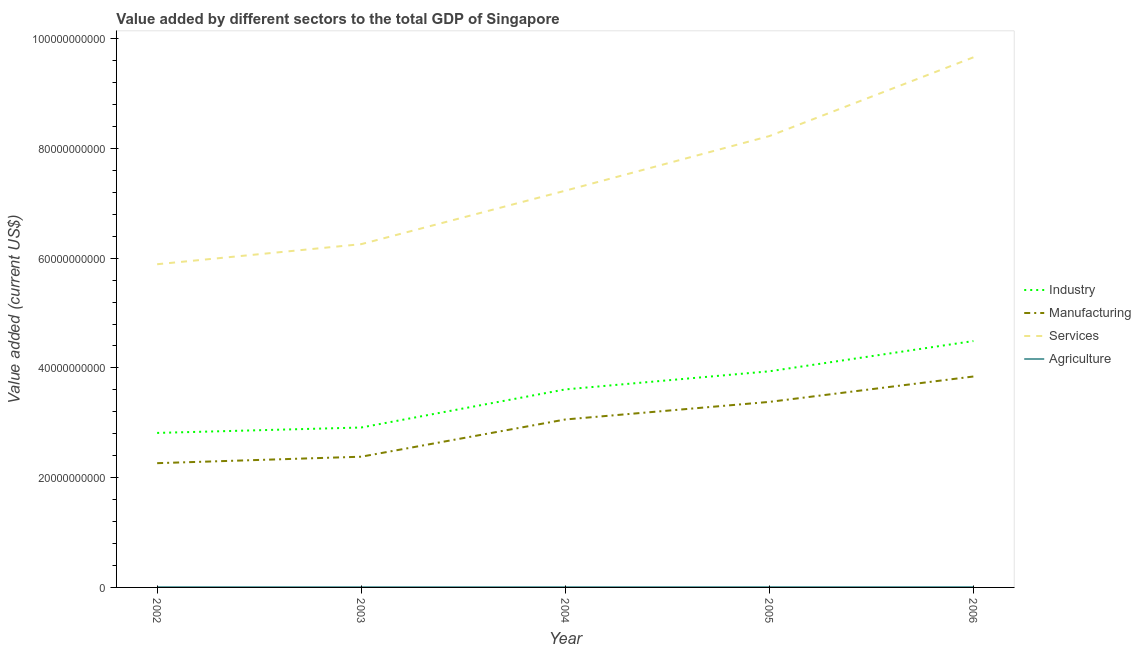Does the line corresponding to value added by services sector intersect with the line corresponding to value added by agricultural sector?
Your answer should be very brief. No. What is the value added by agricultural sector in 2004?
Offer a terse response. 6.39e+07. Across all years, what is the maximum value added by industrial sector?
Your answer should be very brief. 4.49e+1. Across all years, what is the minimum value added by industrial sector?
Ensure brevity in your answer.  2.82e+1. In which year was the value added by manufacturing sector minimum?
Give a very brief answer. 2002. What is the total value added by services sector in the graph?
Give a very brief answer. 3.73e+11. What is the difference between the value added by industrial sector in 2004 and that in 2006?
Your answer should be compact. -8.81e+09. What is the difference between the value added by industrial sector in 2005 and the value added by agricultural sector in 2003?
Keep it short and to the point. 3.93e+1. What is the average value added by manufacturing sector per year?
Offer a terse response. 2.99e+1. In the year 2002, what is the difference between the value added by services sector and value added by industrial sector?
Your response must be concise. 3.07e+1. In how many years, is the value added by services sector greater than 32000000000 US$?
Make the answer very short. 5. What is the ratio of the value added by industrial sector in 2004 to that in 2005?
Ensure brevity in your answer.  0.92. Is the value added by manufacturing sector in 2003 less than that in 2005?
Offer a very short reply. Yes. What is the difference between the highest and the second highest value added by services sector?
Provide a succinct answer. 1.44e+1. What is the difference between the highest and the lowest value added by services sector?
Provide a short and direct response. 3.77e+1. In how many years, is the value added by manufacturing sector greater than the average value added by manufacturing sector taken over all years?
Provide a short and direct response. 3. Is the sum of the value added by industrial sector in 2002 and 2005 greater than the maximum value added by services sector across all years?
Give a very brief answer. No. Is it the case that in every year, the sum of the value added by industrial sector and value added by manufacturing sector is greater than the value added by services sector?
Your answer should be compact. No. Does the value added by manufacturing sector monotonically increase over the years?
Make the answer very short. Yes. How many lines are there?
Keep it short and to the point. 4. Does the graph contain any zero values?
Your answer should be compact. No. Where does the legend appear in the graph?
Your answer should be very brief. Center right. How many legend labels are there?
Your response must be concise. 4. What is the title of the graph?
Ensure brevity in your answer.  Value added by different sectors to the total GDP of Singapore. Does "Pre-primary schools" appear as one of the legend labels in the graph?
Your response must be concise. No. What is the label or title of the X-axis?
Ensure brevity in your answer.  Year. What is the label or title of the Y-axis?
Keep it short and to the point. Value added (current US$). What is the Value added (current US$) of Industry in 2002?
Your answer should be compact. 2.82e+1. What is the Value added (current US$) of Manufacturing in 2002?
Your answer should be compact. 2.26e+1. What is the Value added (current US$) of Services in 2002?
Provide a succinct answer. 5.89e+1. What is the Value added (current US$) in Agriculture in 2002?
Make the answer very short. 6.56e+07. What is the Value added (current US$) in Industry in 2003?
Make the answer very short. 2.91e+1. What is the Value added (current US$) of Manufacturing in 2003?
Make the answer very short. 2.38e+1. What is the Value added (current US$) of Services in 2003?
Keep it short and to the point. 6.26e+1. What is the Value added (current US$) in Agriculture in 2003?
Your response must be concise. 5.96e+07. What is the Value added (current US$) in Industry in 2004?
Provide a succinct answer. 3.61e+1. What is the Value added (current US$) in Manufacturing in 2004?
Offer a terse response. 3.06e+1. What is the Value added (current US$) in Services in 2004?
Offer a very short reply. 7.23e+1. What is the Value added (current US$) of Agriculture in 2004?
Your response must be concise. 6.39e+07. What is the Value added (current US$) of Industry in 2005?
Your answer should be compact. 3.94e+1. What is the Value added (current US$) of Manufacturing in 2005?
Offer a terse response. 3.38e+1. What is the Value added (current US$) in Services in 2005?
Make the answer very short. 8.23e+1. What is the Value added (current US$) in Agriculture in 2005?
Give a very brief answer. 7.02e+07. What is the Value added (current US$) of Industry in 2006?
Provide a succinct answer. 4.49e+1. What is the Value added (current US$) of Manufacturing in 2006?
Provide a short and direct response. 3.84e+1. What is the Value added (current US$) of Services in 2006?
Your response must be concise. 9.66e+1. What is the Value added (current US$) in Agriculture in 2006?
Make the answer very short. 7.24e+07. Across all years, what is the maximum Value added (current US$) of Industry?
Provide a short and direct response. 4.49e+1. Across all years, what is the maximum Value added (current US$) in Manufacturing?
Offer a very short reply. 3.84e+1. Across all years, what is the maximum Value added (current US$) in Services?
Ensure brevity in your answer.  9.66e+1. Across all years, what is the maximum Value added (current US$) in Agriculture?
Give a very brief answer. 7.24e+07. Across all years, what is the minimum Value added (current US$) in Industry?
Your response must be concise. 2.82e+1. Across all years, what is the minimum Value added (current US$) in Manufacturing?
Your response must be concise. 2.26e+1. Across all years, what is the minimum Value added (current US$) in Services?
Your answer should be compact. 5.89e+1. Across all years, what is the minimum Value added (current US$) of Agriculture?
Provide a short and direct response. 5.96e+07. What is the total Value added (current US$) of Industry in the graph?
Offer a terse response. 1.78e+11. What is the total Value added (current US$) in Manufacturing in the graph?
Your response must be concise. 1.49e+11. What is the total Value added (current US$) of Services in the graph?
Ensure brevity in your answer.  3.73e+11. What is the total Value added (current US$) in Agriculture in the graph?
Offer a terse response. 3.32e+08. What is the difference between the Value added (current US$) in Industry in 2002 and that in 2003?
Your answer should be very brief. -9.86e+08. What is the difference between the Value added (current US$) of Manufacturing in 2002 and that in 2003?
Offer a terse response. -1.18e+09. What is the difference between the Value added (current US$) in Services in 2002 and that in 2003?
Provide a short and direct response. -3.66e+09. What is the difference between the Value added (current US$) of Agriculture in 2002 and that in 2003?
Your answer should be compact. 5.98e+06. What is the difference between the Value added (current US$) of Industry in 2002 and that in 2004?
Give a very brief answer. -7.93e+09. What is the difference between the Value added (current US$) in Manufacturing in 2002 and that in 2004?
Provide a succinct answer. -7.96e+09. What is the difference between the Value added (current US$) in Services in 2002 and that in 2004?
Your answer should be compact. -1.34e+1. What is the difference between the Value added (current US$) in Agriculture in 2002 and that in 2004?
Your answer should be compact. 1.67e+06. What is the difference between the Value added (current US$) of Industry in 2002 and that in 2005?
Provide a succinct answer. -1.12e+1. What is the difference between the Value added (current US$) of Manufacturing in 2002 and that in 2005?
Provide a short and direct response. -1.12e+1. What is the difference between the Value added (current US$) in Services in 2002 and that in 2005?
Give a very brief answer. -2.34e+1. What is the difference between the Value added (current US$) in Agriculture in 2002 and that in 2005?
Provide a short and direct response. -4.61e+06. What is the difference between the Value added (current US$) of Industry in 2002 and that in 2006?
Your response must be concise. -1.67e+1. What is the difference between the Value added (current US$) in Manufacturing in 2002 and that in 2006?
Provide a succinct answer. -1.58e+1. What is the difference between the Value added (current US$) of Services in 2002 and that in 2006?
Give a very brief answer. -3.77e+1. What is the difference between the Value added (current US$) in Agriculture in 2002 and that in 2006?
Your answer should be very brief. -6.88e+06. What is the difference between the Value added (current US$) in Industry in 2003 and that in 2004?
Provide a succinct answer. -6.94e+09. What is the difference between the Value added (current US$) in Manufacturing in 2003 and that in 2004?
Keep it short and to the point. -6.78e+09. What is the difference between the Value added (current US$) of Services in 2003 and that in 2004?
Offer a very short reply. -9.74e+09. What is the difference between the Value added (current US$) in Agriculture in 2003 and that in 2004?
Provide a short and direct response. -4.32e+06. What is the difference between the Value added (current US$) of Industry in 2003 and that in 2005?
Offer a terse response. -1.02e+1. What is the difference between the Value added (current US$) in Manufacturing in 2003 and that in 2005?
Give a very brief answer. -9.99e+09. What is the difference between the Value added (current US$) of Services in 2003 and that in 2005?
Your response must be concise. -1.97e+1. What is the difference between the Value added (current US$) in Agriculture in 2003 and that in 2005?
Your response must be concise. -1.06e+07. What is the difference between the Value added (current US$) in Industry in 2003 and that in 2006?
Make the answer very short. -1.58e+1. What is the difference between the Value added (current US$) of Manufacturing in 2003 and that in 2006?
Offer a terse response. -1.46e+1. What is the difference between the Value added (current US$) in Services in 2003 and that in 2006?
Offer a terse response. -3.41e+1. What is the difference between the Value added (current US$) in Agriculture in 2003 and that in 2006?
Ensure brevity in your answer.  -1.29e+07. What is the difference between the Value added (current US$) of Industry in 2004 and that in 2005?
Your response must be concise. -3.30e+09. What is the difference between the Value added (current US$) of Manufacturing in 2004 and that in 2005?
Provide a succinct answer. -3.21e+09. What is the difference between the Value added (current US$) of Services in 2004 and that in 2005?
Ensure brevity in your answer.  -9.95e+09. What is the difference between the Value added (current US$) in Agriculture in 2004 and that in 2005?
Offer a terse response. -6.28e+06. What is the difference between the Value added (current US$) in Industry in 2004 and that in 2006?
Provide a succinct answer. -8.81e+09. What is the difference between the Value added (current US$) of Manufacturing in 2004 and that in 2006?
Your answer should be very brief. -7.83e+09. What is the difference between the Value added (current US$) in Services in 2004 and that in 2006?
Your answer should be compact. -2.43e+1. What is the difference between the Value added (current US$) in Agriculture in 2004 and that in 2006?
Your answer should be compact. -8.54e+06. What is the difference between the Value added (current US$) of Industry in 2005 and that in 2006?
Provide a succinct answer. -5.51e+09. What is the difference between the Value added (current US$) in Manufacturing in 2005 and that in 2006?
Ensure brevity in your answer.  -4.63e+09. What is the difference between the Value added (current US$) of Services in 2005 and that in 2006?
Offer a terse response. -1.44e+1. What is the difference between the Value added (current US$) of Agriculture in 2005 and that in 2006?
Give a very brief answer. -2.26e+06. What is the difference between the Value added (current US$) in Industry in 2002 and the Value added (current US$) in Manufacturing in 2003?
Give a very brief answer. 4.33e+09. What is the difference between the Value added (current US$) in Industry in 2002 and the Value added (current US$) in Services in 2003?
Provide a short and direct response. -3.44e+1. What is the difference between the Value added (current US$) in Industry in 2002 and the Value added (current US$) in Agriculture in 2003?
Give a very brief answer. 2.81e+1. What is the difference between the Value added (current US$) of Manufacturing in 2002 and the Value added (current US$) of Services in 2003?
Your response must be concise. -3.99e+1. What is the difference between the Value added (current US$) in Manufacturing in 2002 and the Value added (current US$) in Agriculture in 2003?
Offer a terse response. 2.26e+1. What is the difference between the Value added (current US$) of Services in 2002 and the Value added (current US$) of Agriculture in 2003?
Offer a terse response. 5.88e+1. What is the difference between the Value added (current US$) in Industry in 2002 and the Value added (current US$) in Manufacturing in 2004?
Your answer should be very brief. -2.45e+09. What is the difference between the Value added (current US$) in Industry in 2002 and the Value added (current US$) in Services in 2004?
Your response must be concise. -4.41e+1. What is the difference between the Value added (current US$) of Industry in 2002 and the Value added (current US$) of Agriculture in 2004?
Keep it short and to the point. 2.81e+1. What is the difference between the Value added (current US$) of Manufacturing in 2002 and the Value added (current US$) of Services in 2004?
Offer a very short reply. -4.97e+1. What is the difference between the Value added (current US$) of Manufacturing in 2002 and the Value added (current US$) of Agriculture in 2004?
Ensure brevity in your answer.  2.26e+1. What is the difference between the Value added (current US$) in Services in 2002 and the Value added (current US$) in Agriculture in 2004?
Ensure brevity in your answer.  5.88e+1. What is the difference between the Value added (current US$) in Industry in 2002 and the Value added (current US$) in Manufacturing in 2005?
Offer a terse response. -5.66e+09. What is the difference between the Value added (current US$) in Industry in 2002 and the Value added (current US$) in Services in 2005?
Your answer should be compact. -5.41e+1. What is the difference between the Value added (current US$) of Industry in 2002 and the Value added (current US$) of Agriculture in 2005?
Provide a short and direct response. 2.81e+1. What is the difference between the Value added (current US$) in Manufacturing in 2002 and the Value added (current US$) in Services in 2005?
Make the answer very short. -5.96e+1. What is the difference between the Value added (current US$) in Manufacturing in 2002 and the Value added (current US$) in Agriculture in 2005?
Make the answer very short. 2.26e+1. What is the difference between the Value added (current US$) in Services in 2002 and the Value added (current US$) in Agriculture in 2005?
Ensure brevity in your answer.  5.88e+1. What is the difference between the Value added (current US$) in Industry in 2002 and the Value added (current US$) in Manufacturing in 2006?
Your answer should be compact. -1.03e+1. What is the difference between the Value added (current US$) in Industry in 2002 and the Value added (current US$) in Services in 2006?
Make the answer very short. -6.85e+1. What is the difference between the Value added (current US$) of Industry in 2002 and the Value added (current US$) of Agriculture in 2006?
Make the answer very short. 2.81e+1. What is the difference between the Value added (current US$) of Manufacturing in 2002 and the Value added (current US$) of Services in 2006?
Your answer should be very brief. -7.40e+1. What is the difference between the Value added (current US$) of Manufacturing in 2002 and the Value added (current US$) of Agriculture in 2006?
Your response must be concise. 2.26e+1. What is the difference between the Value added (current US$) of Services in 2002 and the Value added (current US$) of Agriculture in 2006?
Give a very brief answer. 5.88e+1. What is the difference between the Value added (current US$) in Industry in 2003 and the Value added (current US$) in Manufacturing in 2004?
Your answer should be compact. -1.46e+09. What is the difference between the Value added (current US$) in Industry in 2003 and the Value added (current US$) in Services in 2004?
Give a very brief answer. -4.32e+1. What is the difference between the Value added (current US$) of Industry in 2003 and the Value added (current US$) of Agriculture in 2004?
Offer a terse response. 2.91e+1. What is the difference between the Value added (current US$) in Manufacturing in 2003 and the Value added (current US$) in Services in 2004?
Your answer should be very brief. -4.85e+1. What is the difference between the Value added (current US$) of Manufacturing in 2003 and the Value added (current US$) of Agriculture in 2004?
Provide a short and direct response. 2.38e+1. What is the difference between the Value added (current US$) in Services in 2003 and the Value added (current US$) in Agriculture in 2004?
Provide a succinct answer. 6.25e+1. What is the difference between the Value added (current US$) of Industry in 2003 and the Value added (current US$) of Manufacturing in 2005?
Keep it short and to the point. -4.67e+09. What is the difference between the Value added (current US$) of Industry in 2003 and the Value added (current US$) of Services in 2005?
Your answer should be compact. -5.31e+1. What is the difference between the Value added (current US$) in Industry in 2003 and the Value added (current US$) in Agriculture in 2005?
Your answer should be very brief. 2.91e+1. What is the difference between the Value added (current US$) in Manufacturing in 2003 and the Value added (current US$) in Services in 2005?
Your answer should be very brief. -5.84e+1. What is the difference between the Value added (current US$) of Manufacturing in 2003 and the Value added (current US$) of Agriculture in 2005?
Offer a terse response. 2.38e+1. What is the difference between the Value added (current US$) in Services in 2003 and the Value added (current US$) in Agriculture in 2005?
Ensure brevity in your answer.  6.25e+1. What is the difference between the Value added (current US$) of Industry in 2003 and the Value added (current US$) of Manufacturing in 2006?
Ensure brevity in your answer.  -9.30e+09. What is the difference between the Value added (current US$) of Industry in 2003 and the Value added (current US$) of Services in 2006?
Offer a terse response. -6.75e+1. What is the difference between the Value added (current US$) of Industry in 2003 and the Value added (current US$) of Agriculture in 2006?
Keep it short and to the point. 2.91e+1. What is the difference between the Value added (current US$) in Manufacturing in 2003 and the Value added (current US$) in Services in 2006?
Provide a short and direct response. -7.28e+1. What is the difference between the Value added (current US$) of Manufacturing in 2003 and the Value added (current US$) of Agriculture in 2006?
Provide a short and direct response. 2.38e+1. What is the difference between the Value added (current US$) of Services in 2003 and the Value added (current US$) of Agriculture in 2006?
Make the answer very short. 6.25e+1. What is the difference between the Value added (current US$) in Industry in 2004 and the Value added (current US$) in Manufacturing in 2005?
Provide a succinct answer. 2.27e+09. What is the difference between the Value added (current US$) of Industry in 2004 and the Value added (current US$) of Services in 2005?
Provide a short and direct response. -4.62e+1. What is the difference between the Value added (current US$) of Industry in 2004 and the Value added (current US$) of Agriculture in 2005?
Give a very brief answer. 3.60e+1. What is the difference between the Value added (current US$) of Manufacturing in 2004 and the Value added (current US$) of Services in 2005?
Make the answer very short. -5.16e+1. What is the difference between the Value added (current US$) in Manufacturing in 2004 and the Value added (current US$) in Agriculture in 2005?
Your answer should be very brief. 3.05e+1. What is the difference between the Value added (current US$) of Services in 2004 and the Value added (current US$) of Agriculture in 2005?
Your answer should be very brief. 7.22e+1. What is the difference between the Value added (current US$) in Industry in 2004 and the Value added (current US$) in Manufacturing in 2006?
Your answer should be compact. -2.35e+09. What is the difference between the Value added (current US$) of Industry in 2004 and the Value added (current US$) of Services in 2006?
Keep it short and to the point. -6.05e+1. What is the difference between the Value added (current US$) of Industry in 2004 and the Value added (current US$) of Agriculture in 2006?
Your answer should be very brief. 3.60e+1. What is the difference between the Value added (current US$) in Manufacturing in 2004 and the Value added (current US$) in Services in 2006?
Provide a short and direct response. -6.60e+1. What is the difference between the Value added (current US$) in Manufacturing in 2004 and the Value added (current US$) in Agriculture in 2006?
Your response must be concise. 3.05e+1. What is the difference between the Value added (current US$) of Services in 2004 and the Value added (current US$) of Agriculture in 2006?
Provide a short and direct response. 7.22e+1. What is the difference between the Value added (current US$) in Industry in 2005 and the Value added (current US$) in Manufacturing in 2006?
Give a very brief answer. 9.48e+08. What is the difference between the Value added (current US$) of Industry in 2005 and the Value added (current US$) of Services in 2006?
Offer a terse response. -5.72e+1. What is the difference between the Value added (current US$) in Industry in 2005 and the Value added (current US$) in Agriculture in 2006?
Offer a terse response. 3.93e+1. What is the difference between the Value added (current US$) in Manufacturing in 2005 and the Value added (current US$) in Services in 2006?
Make the answer very short. -6.28e+1. What is the difference between the Value added (current US$) in Manufacturing in 2005 and the Value added (current US$) in Agriculture in 2006?
Ensure brevity in your answer.  3.37e+1. What is the difference between the Value added (current US$) in Services in 2005 and the Value added (current US$) in Agriculture in 2006?
Your response must be concise. 8.22e+1. What is the average Value added (current US$) of Industry per year?
Offer a terse response. 3.55e+1. What is the average Value added (current US$) of Manufacturing per year?
Your answer should be very brief. 2.99e+1. What is the average Value added (current US$) of Services per year?
Make the answer very short. 7.45e+1. What is the average Value added (current US$) in Agriculture per year?
Your response must be concise. 6.63e+07. In the year 2002, what is the difference between the Value added (current US$) in Industry and Value added (current US$) in Manufacturing?
Your answer should be compact. 5.51e+09. In the year 2002, what is the difference between the Value added (current US$) of Industry and Value added (current US$) of Services?
Ensure brevity in your answer.  -3.07e+1. In the year 2002, what is the difference between the Value added (current US$) in Industry and Value added (current US$) in Agriculture?
Your response must be concise. 2.81e+1. In the year 2002, what is the difference between the Value added (current US$) of Manufacturing and Value added (current US$) of Services?
Offer a terse response. -3.63e+1. In the year 2002, what is the difference between the Value added (current US$) in Manufacturing and Value added (current US$) in Agriculture?
Your answer should be compact. 2.26e+1. In the year 2002, what is the difference between the Value added (current US$) of Services and Value added (current US$) of Agriculture?
Make the answer very short. 5.88e+1. In the year 2003, what is the difference between the Value added (current US$) in Industry and Value added (current US$) in Manufacturing?
Your response must be concise. 5.32e+09. In the year 2003, what is the difference between the Value added (current US$) of Industry and Value added (current US$) of Services?
Your response must be concise. -3.34e+1. In the year 2003, what is the difference between the Value added (current US$) of Industry and Value added (current US$) of Agriculture?
Give a very brief answer. 2.91e+1. In the year 2003, what is the difference between the Value added (current US$) in Manufacturing and Value added (current US$) in Services?
Keep it short and to the point. -3.87e+1. In the year 2003, what is the difference between the Value added (current US$) in Manufacturing and Value added (current US$) in Agriculture?
Provide a short and direct response. 2.38e+1. In the year 2003, what is the difference between the Value added (current US$) of Services and Value added (current US$) of Agriculture?
Provide a succinct answer. 6.25e+1. In the year 2004, what is the difference between the Value added (current US$) of Industry and Value added (current US$) of Manufacturing?
Your answer should be very brief. 5.48e+09. In the year 2004, what is the difference between the Value added (current US$) of Industry and Value added (current US$) of Services?
Ensure brevity in your answer.  -3.62e+1. In the year 2004, what is the difference between the Value added (current US$) of Industry and Value added (current US$) of Agriculture?
Offer a terse response. 3.60e+1. In the year 2004, what is the difference between the Value added (current US$) of Manufacturing and Value added (current US$) of Services?
Your response must be concise. -4.17e+1. In the year 2004, what is the difference between the Value added (current US$) in Manufacturing and Value added (current US$) in Agriculture?
Give a very brief answer. 3.05e+1. In the year 2004, what is the difference between the Value added (current US$) of Services and Value added (current US$) of Agriculture?
Offer a terse response. 7.22e+1. In the year 2005, what is the difference between the Value added (current US$) in Industry and Value added (current US$) in Manufacturing?
Your answer should be very brief. 5.57e+09. In the year 2005, what is the difference between the Value added (current US$) in Industry and Value added (current US$) in Services?
Offer a terse response. -4.29e+1. In the year 2005, what is the difference between the Value added (current US$) in Industry and Value added (current US$) in Agriculture?
Make the answer very short. 3.93e+1. In the year 2005, what is the difference between the Value added (current US$) in Manufacturing and Value added (current US$) in Services?
Keep it short and to the point. -4.84e+1. In the year 2005, what is the difference between the Value added (current US$) of Manufacturing and Value added (current US$) of Agriculture?
Make the answer very short. 3.37e+1. In the year 2005, what is the difference between the Value added (current US$) of Services and Value added (current US$) of Agriculture?
Keep it short and to the point. 8.22e+1. In the year 2006, what is the difference between the Value added (current US$) of Industry and Value added (current US$) of Manufacturing?
Your answer should be very brief. 6.46e+09. In the year 2006, what is the difference between the Value added (current US$) in Industry and Value added (current US$) in Services?
Give a very brief answer. -5.17e+1. In the year 2006, what is the difference between the Value added (current US$) in Industry and Value added (current US$) in Agriculture?
Keep it short and to the point. 4.48e+1. In the year 2006, what is the difference between the Value added (current US$) in Manufacturing and Value added (current US$) in Services?
Your answer should be very brief. -5.82e+1. In the year 2006, what is the difference between the Value added (current US$) in Manufacturing and Value added (current US$) in Agriculture?
Provide a short and direct response. 3.84e+1. In the year 2006, what is the difference between the Value added (current US$) of Services and Value added (current US$) of Agriculture?
Make the answer very short. 9.65e+1. What is the ratio of the Value added (current US$) in Industry in 2002 to that in 2003?
Provide a succinct answer. 0.97. What is the ratio of the Value added (current US$) in Manufacturing in 2002 to that in 2003?
Offer a very short reply. 0.95. What is the ratio of the Value added (current US$) in Services in 2002 to that in 2003?
Make the answer very short. 0.94. What is the ratio of the Value added (current US$) of Agriculture in 2002 to that in 2003?
Offer a very short reply. 1.1. What is the ratio of the Value added (current US$) in Industry in 2002 to that in 2004?
Offer a terse response. 0.78. What is the ratio of the Value added (current US$) in Manufacturing in 2002 to that in 2004?
Provide a succinct answer. 0.74. What is the ratio of the Value added (current US$) of Services in 2002 to that in 2004?
Your answer should be compact. 0.81. What is the ratio of the Value added (current US$) of Agriculture in 2002 to that in 2004?
Ensure brevity in your answer.  1.03. What is the ratio of the Value added (current US$) of Industry in 2002 to that in 2005?
Your response must be concise. 0.71. What is the ratio of the Value added (current US$) of Manufacturing in 2002 to that in 2005?
Provide a succinct answer. 0.67. What is the ratio of the Value added (current US$) of Services in 2002 to that in 2005?
Offer a very short reply. 0.72. What is the ratio of the Value added (current US$) in Agriculture in 2002 to that in 2005?
Your response must be concise. 0.93. What is the ratio of the Value added (current US$) in Industry in 2002 to that in 2006?
Make the answer very short. 0.63. What is the ratio of the Value added (current US$) of Manufacturing in 2002 to that in 2006?
Provide a succinct answer. 0.59. What is the ratio of the Value added (current US$) of Services in 2002 to that in 2006?
Offer a very short reply. 0.61. What is the ratio of the Value added (current US$) of Agriculture in 2002 to that in 2006?
Keep it short and to the point. 0.91. What is the ratio of the Value added (current US$) of Industry in 2003 to that in 2004?
Provide a short and direct response. 0.81. What is the ratio of the Value added (current US$) in Manufacturing in 2003 to that in 2004?
Make the answer very short. 0.78. What is the ratio of the Value added (current US$) in Services in 2003 to that in 2004?
Your answer should be very brief. 0.87. What is the ratio of the Value added (current US$) of Agriculture in 2003 to that in 2004?
Your response must be concise. 0.93. What is the ratio of the Value added (current US$) in Industry in 2003 to that in 2005?
Offer a terse response. 0.74. What is the ratio of the Value added (current US$) in Manufacturing in 2003 to that in 2005?
Your answer should be very brief. 0.7. What is the ratio of the Value added (current US$) of Services in 2003 to that in 2005?
Your answer should be compact. 0.76. What is the ratio of the Value added (current US$) of Agriculture in 2003 to that in 2005?
Keep it short and to the point. 0.85. What is the ratio of the Value added (current US$) of Industry in 2003 to that in 2006?
Keep it short and to the point. 0.65. What is the ratio of the Value added (current US$) in Manufacturing in 2003 to that in 2006?
Your response must be concise. 0.62. What is the ratio of the Value added (current US$) in Services in 2003 to that in 2006?
Offer a terse response. 0.65. What is the ratio of the Value added (current US$) of Agriculture in 2003 to that in 2006?
Your answer should be very brief. 0.82. What is the ratio of the Value added (current US$) of Industry in 2004 to that in 2005?
Your answer should be very brief. 0.92. What is the ratio of the Value added (current US$) in Manufacturing in 2004 to that in 2005?
Give a very brief answer. 0.91. What is the ratio of the Value added (current US$) in Services in 2004 to that in 2005?
Give a very brief answer. 0.88. What is the ratio of the Value added (current US$) in Agriculture in 2004 to that in 2005?
Your answer should be compact. 0.91. What is the ratio of the Value added (current US$) of Industry in 2004 to that in 2006?
Your response must be concise. 0.8. What is the ratio of the Value added (current US$) in Manufacturing in 2004 to that in 2006?
Ensure brevity in your answer.  0.8. What is the ratio of the Value added (current US$) in Services in 2004 to that in 2006?
Provide a succinct answer. 0.75. What is the ratio of the Value added (current US$) in Agriculture in 2004 to that in 2006?
Offer a terse response. 0.88. What is the ratio of the Value added (current US$) in Industry in 2005 to that in 2006?
Ensure brevity in your answer.  0.88. What is the ratio of the Value added (current US$) of Manufacturing in 2005 to that in 2006?
Keep it short and to the point. 0.88. What is the ratio of the Value added (current US$) in Services in 2005 to that in 2006?
Keep it short and to the point. 0.85. What is the ratio of the Value added (current US$) of Agriculture in 2005 to that in 2006?
Provide a succinct answer. 0.97. What is the difference between the highest and the second highest Value added (current US$) in Industry?
Make the answer very short. 5.51e+09. What is the difference between the highest and the second highest Value added (current US$) in Manufacturing?
Your answer should be compact. 4.63e+09. What is the difference between the highest and the second highest Value added (current US$) in Services?
Provide a succinct answer. 1.44e+1. What is the difference between the highest and the second highest Value added (current US$) in Agriculture?
Offer a very short reply. 2.26e+06. What is the difference between the highest and the lowest Value added (current US$) of Industry?
Your answer should be compact. 1.67e+1. What is the difference between the highest and the lowest Value added (current US$) of Manufacturing?
Offer a terse response. 1.58e+1. What is the difference between the highest and the lowest Value added (current US$) of Services?
Ensure brevity in your answer.  3.77e+1. What is the difference between the highest and the lowest Value added (current US$) of Agriculture?
Ensure brevity in your answer.  1.29e+07. 